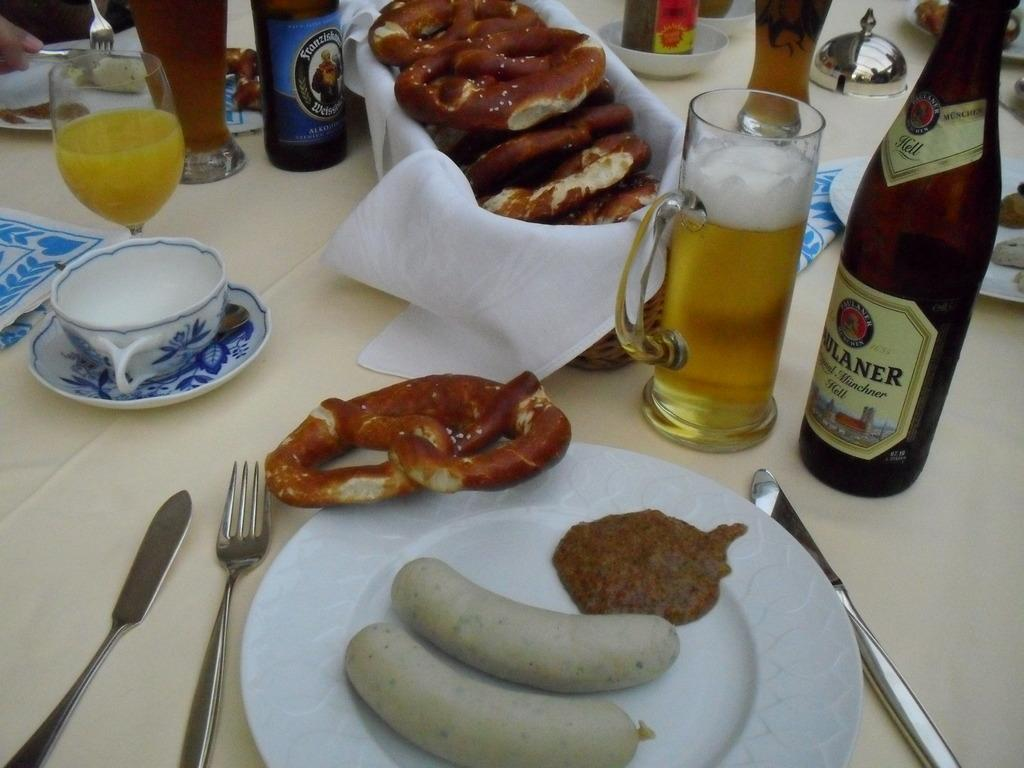What piece of furniture is present in the image? There is a table in the image. What is placed on the table? There is a cup on a saucer and a glass filled with juice on the table. What is the other glass filled with? The other glass is filled with a drink. How are the drink and the bottle related in the image? The drink is near a bottle on the table. What other objects can be seen on the table? There are other objects on the table. How many boys are playing with the circle in the image? There are no boys or circles present in the image. 